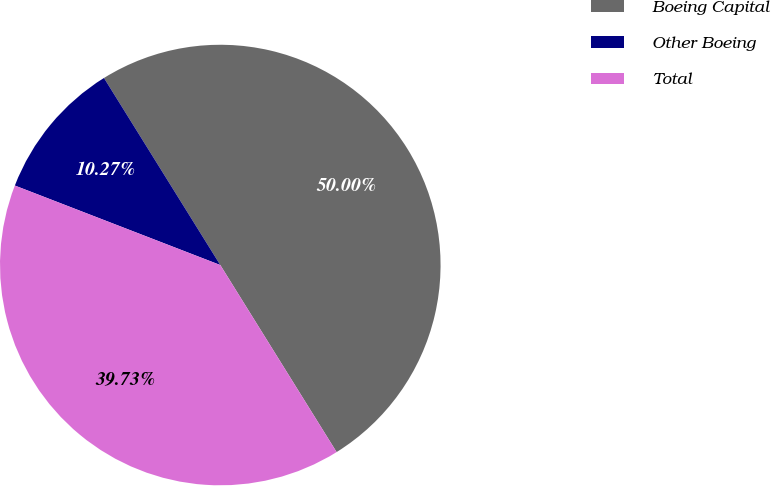Convert chart. <chart><loc_0><loc_0><loc_500><loc_500><pie_chart><fcel>Boeing Capital<fcel>Other Boeing<fcel>Total<nl><fcel>50.0%<fcel>10.27%<fcel>39.73%<nl></chart> 